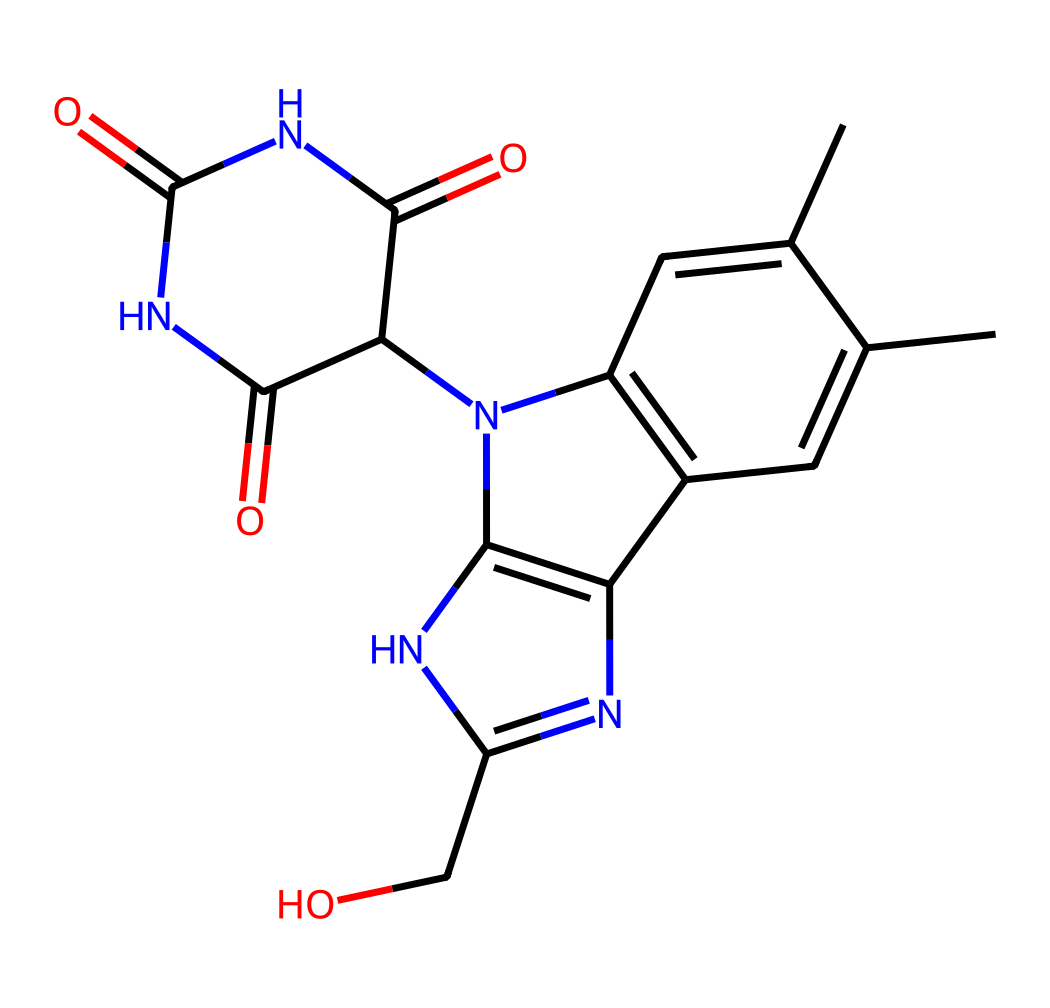What is the chemical name for the substance represented by this SMILES? The SMILES denotes the structure of Riboflavin, which is a type of vitamin. The full name can be confirmed by matching the structure and looking up known compounds.
Answer: Riboflavin How many carbon atoms are present in this molecule? The structure contains a total of 17 carbon atoms (C) when counted from the visual representation. Each vertex and endpoint in the line structure corresponds to a carbon atom.
Answer: 17 What type of functional group is prevalent in this vitamin? The molecule has multiple nitrogen atoms which indicate the presence of amine and amide functional groups. These groups play vital roles in its biochemical activities.
Answer: Amine and amide Is this compound a water-soluble vitamin? Riboflavin is classified as a water-soluble vitamin, which is determined by its structure and behavior in aqueous solutions.
Answer: Yes What is the primary color associated with Riboflavin when used as a colorant? Riboflavin imparts a yellow color, which can be observed when the compound is used in solutions or as a dye.
Answer: Yellow How many nitrogen atoms are found in this molecule? By analyzing the SMILES representation, there are 5 nitrogen atoms (N) present in the chemical structure, indicated by the positions of N in the formula.
Answer: 5 Could Riboflavin be used safely in art supplies for coloring? Since Riboflavin is a natural compound considered safe for consumption, its use in art supplies for coloring can be deemed safe as well.
Answer: Yes 